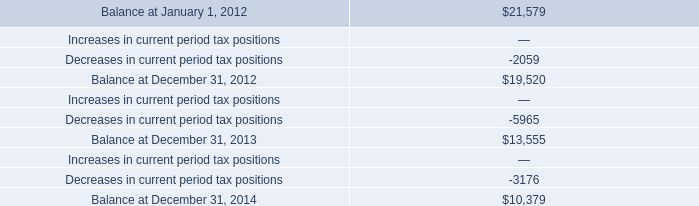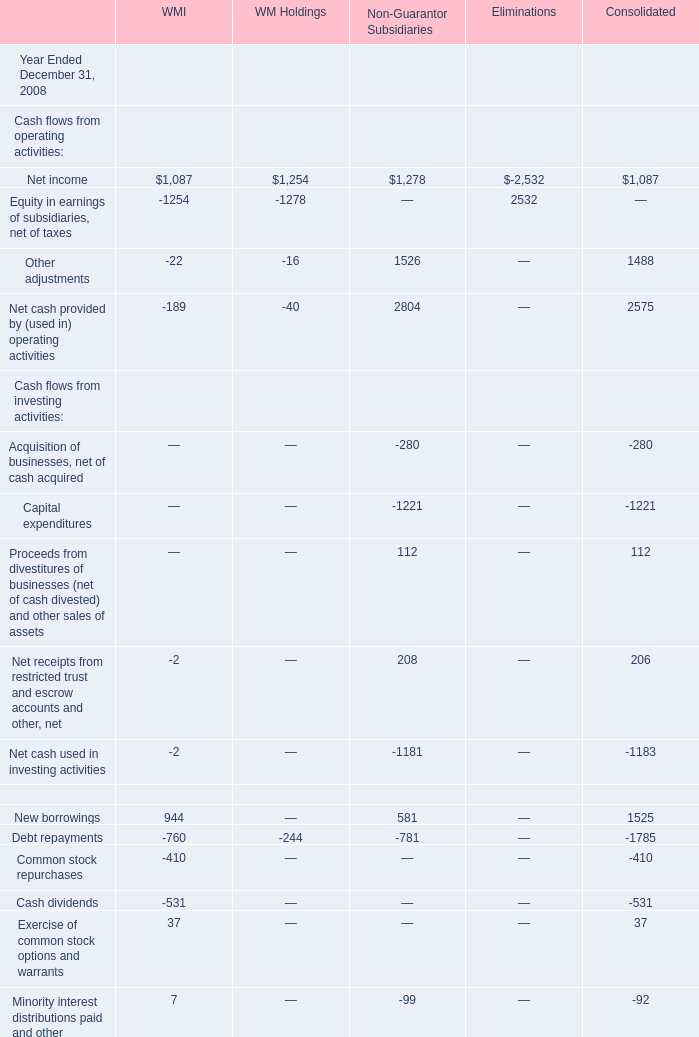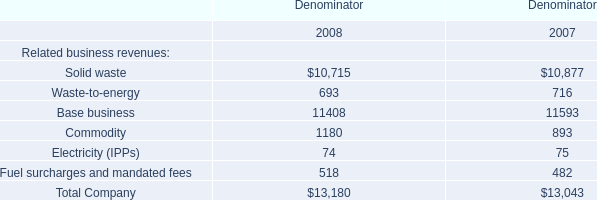What's the average of Net income of WMI, and Commodity of Denominator 2008 ? 
Computations: ((1087.0 + 1180.0) / 2)
Answer: 1133.5. 